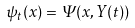<formula> <loc_0><loc_0><loc_500><loc_500>\psi _ { t } ( x ) = \Psi ( x , Y ( t ) )</formula> 